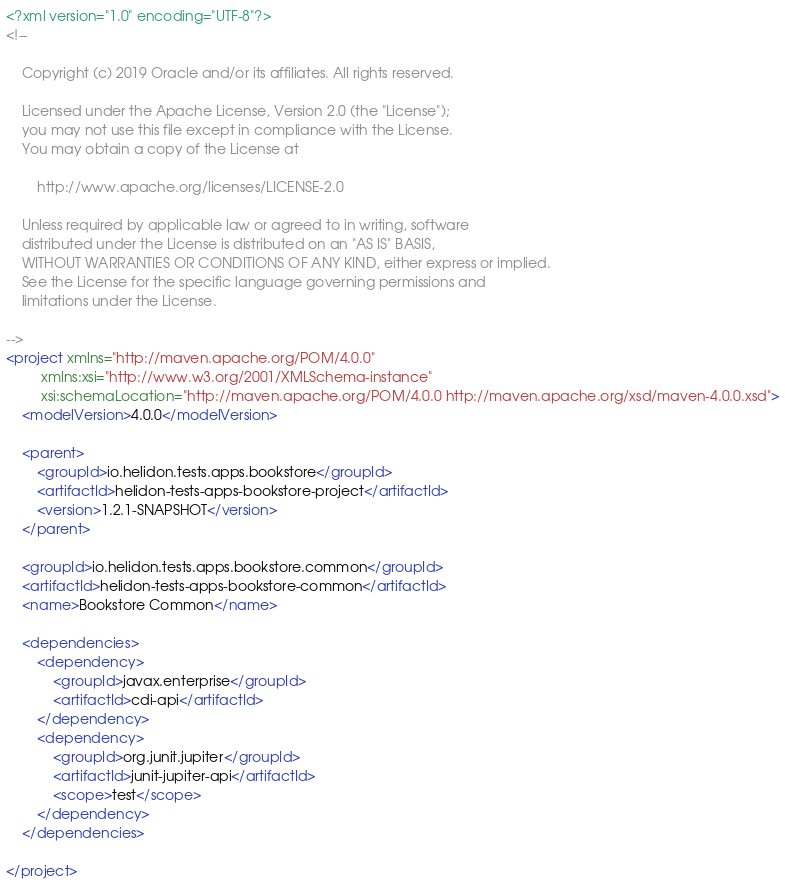<code> <loc_0><loc_0><loc_500><loc_500><_XML_><?xml version="1.0" encoding="UTF-8"?>
<!--

    Copyright (c) 2019 Oracle and/or its affiliates. All rights reserved.

    Licensed under the Apache License, Version 2.0 (the "License");
    you may not use this file except in compliance with the License.
    You may obtain a copy of the License at

        http://www.apache.org/licenses/LICENSE-2.0

    Unless required by applicable law or agreed to in writing, software
    distributed under the License is distributed on an "AS IS" BASIS,
    WITHOUT WARRANTIES OR CONDITIONS OF ANY KIND, either express or implied.
    See the License for the specific language governing permissions and
    limitations under the License.

-->
<project xmlns="http://maven.apache.org/POM/4.0.0"
         xmlns:xsi="http://www.w3.org/2001/XMLSchema-instance"
         xsi:schemaLocation="http://maven.apache.org/POM/4.0.0 http://maven.apache.org/xsd/maven-4.0.0.xsd">
    <modelVersion>4.0.0</modelVersion>

    <parent>
        <groupId>io.helidon.tests.apps.bookstore</groupId>
        <artifactId>helidon-tests-apps-bookstore-project</artifactId>
        <version>1.2.1-SNAPSHOT</version>
    </parent>

    <groupId>io.helidon.tests.apps.bookstore.common</groupId>
    <artifactId>helidon-tests-apps-bookstore-common</artifactId>
    <name>Bookstore Common</name>

    <dependencies>
        <dependency>
            <groupId>javax.enterprise</groupId>
            <artifactId>cdi-api</artifactId>
        </dependency>
        <dependency>
            <groupId>org.junit.jupiter</groupId>
            <artifactId>junit-jupiter-api</artifactId>
            <scope>test</scope>
        </dependency>
    </dependencies>

</project>
</code> 